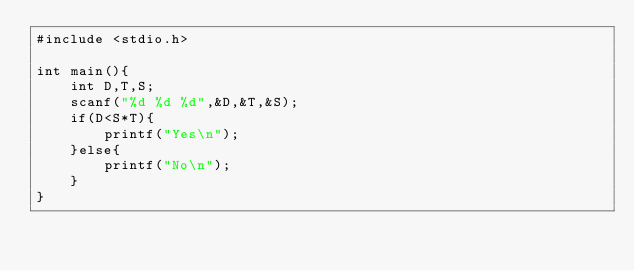<code> <loc_0><loc_0><loc_500><loc_500><_C_>#include <stdio.h>

int main(){
    int D,T,S;
    scanf("%d %d %d",&D,&T,&S);
    if(D<S*T){
        printf("Yes\n");
    }else{
        printf("No\n");
    }
}</code> 